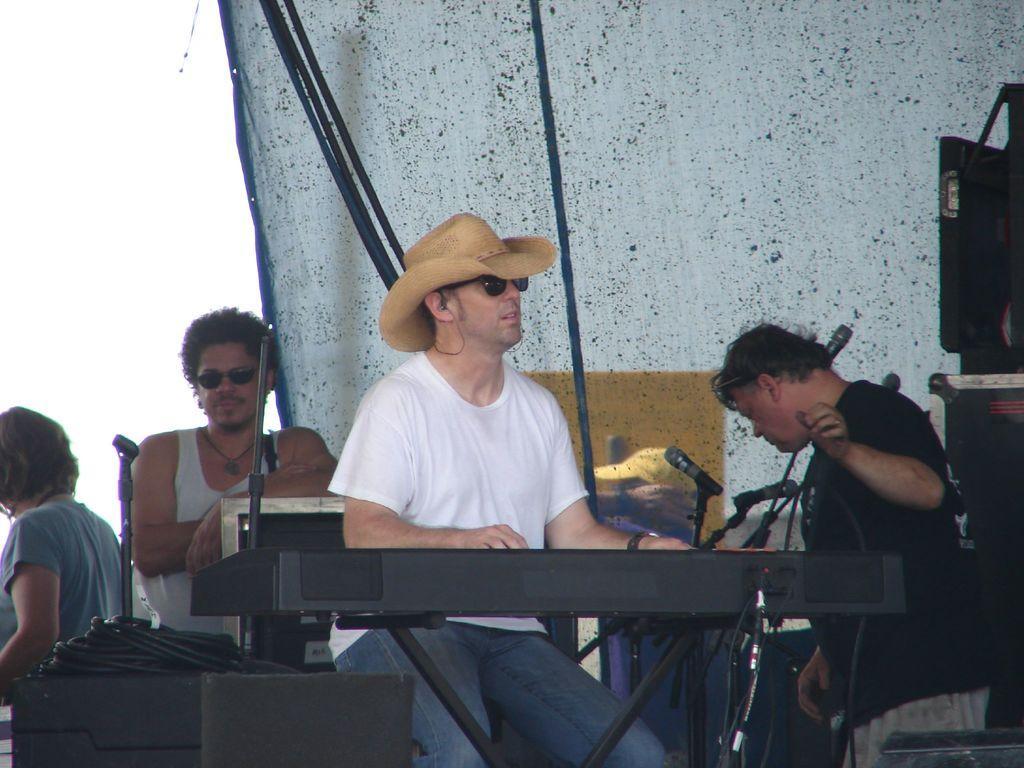In one or two sentences, can you explain what this image depicts? In this image, there are a few people, musical instruments, microphones. We can also see some objects on the right. We can see some strands and wires. We can also see some cloth and some objects at the bottom. We can also see the sky. 